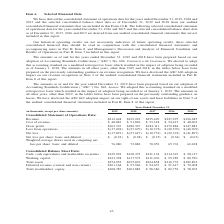From A10 Networks's financial document, What are the years included in the consolidated statement of operations? The document contains multiple relevant values: 2019, 2018, 2017, 2016, 2015. From the document: "31, (in thousands, except per share amounts) 2019 2018 2017 2016 2015 mber 31, (in thousands, except per share amounts) 2019 2018 2017 2016 2015 ousan..." Also, What is the accounting standards used to prepare the financial statements? Accounting Standards Codification. The document states: "2018 have been prepared based on our adoption of Accounting Standards Codification (‘‘ASC’’) No. 606, Contracts with Customers . We elected to adopt t..." Also, What is the total revenue earned by the company in 2019? According to the financial document, $212,628. The relevant text states: "nsolidated Statement of Operations Data: Revenue . $212,628 $232,223 $235,429 $227,297 $196,285 Cost of revenue . $ 48,881 $ 51,896 $ 53,318 $ 54,413 $ 48,402 G..." Also, can you calculate: What is the percentage change in revenue between 2018 and 2019? To answer this question, I need to perform calculations using the financial data. The calculation is: ($212,628-$232,223)/$232,223, which equals -8.44 (percentage). This is based on the information: "Statement of Operations Data: Revenue . $212,628 $232,223 $235,429 $227,297 $196,285 Cost of revenue . $ 48,881 $ 51,896 $ 53,318 $ 54,413 $ 48,402 Gross pro olidated Statement of Operations Data: Rev..." The key data points involved are: 212,628, 232,223. Also, can you calculate: What is the percentage change in gross profit between 2018 and 2019? To answer this question, I need to perform calculations using the financial data. The calculation is: (163,747-180,327)/180,327 , which equals -9.19 (percentage). This is based on the information: "53,318 $ 54,413 $ 48,402 Gross profit . $163,747 $180,327 $182,111 $172,884 $147,883 Loss from operations . $ (17,094) $ (27,679) $ (10,372) $ (20,570) $ (40 51,896 $ 53,318 $ 54,413 $ 48,402 Gross pr..." The key data points involved are: 163,747, 180,327. Also, can you calculate: What is the total revenue earned by the company between 2015 to 2019? Based on the calculation: 212,628+232,223+235,429+227,297, the result is 907577 (in thousands). This is based on the information: "Statement of Operations Data: Revenue . $212,628 $232,223 $235,429 $227,297 $196,285 Cost of revenue . $ 48,881 $ 51,896 $ 53,318 $ 54,413 $ 48,402 Gross pro tions Data: Revenue . $212,628 $232,223 $2..." The key data points involved are: 212,628, 227,297, 232,223. 